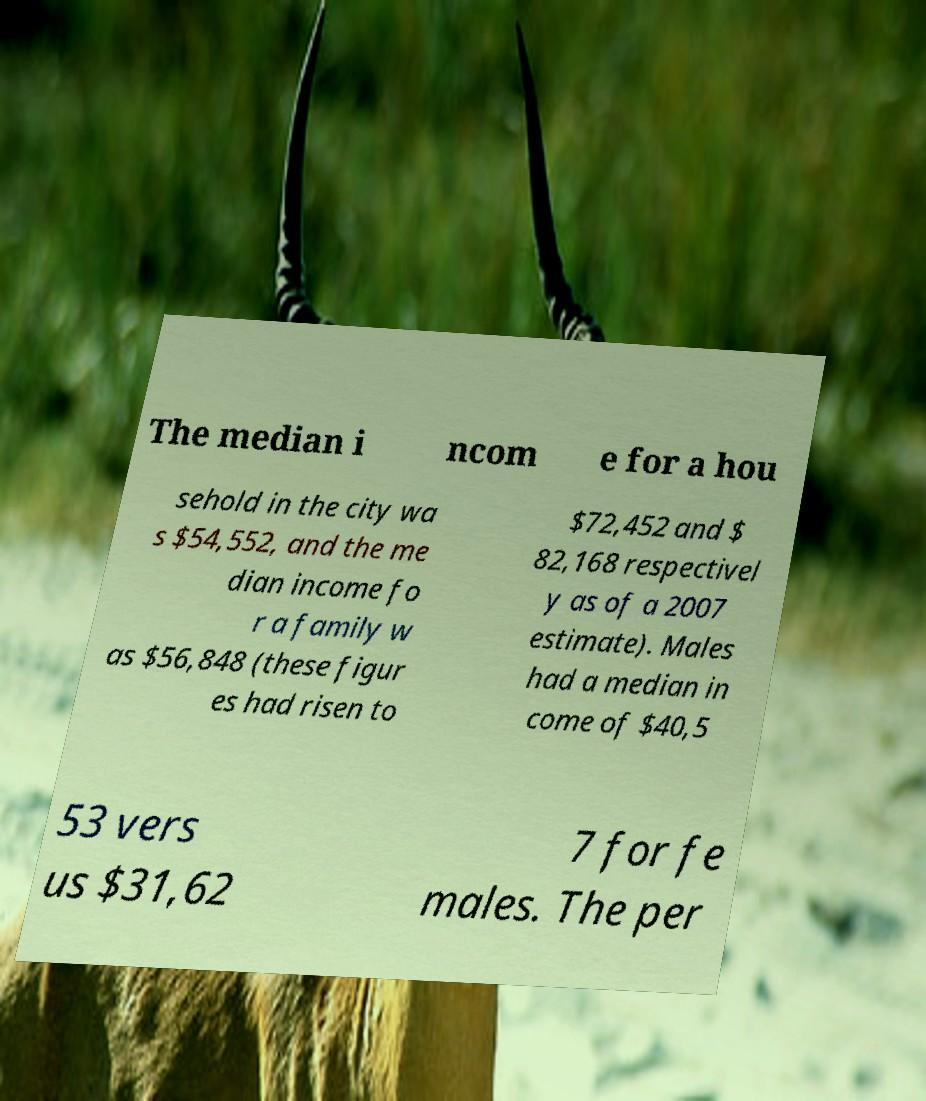I need the written content from this picture converted into text. Can you do that? The median i ncom e for a hou sehold in the city wa s $54,552, and the me dian income fo r a family w as $56,848 (these figur es had risen to $72,452 and $ 82,168 respectivel y as of a 2007 estimate). Males had a median in come of $40,5 53 vers us $31,62 7 for fe males. The per 